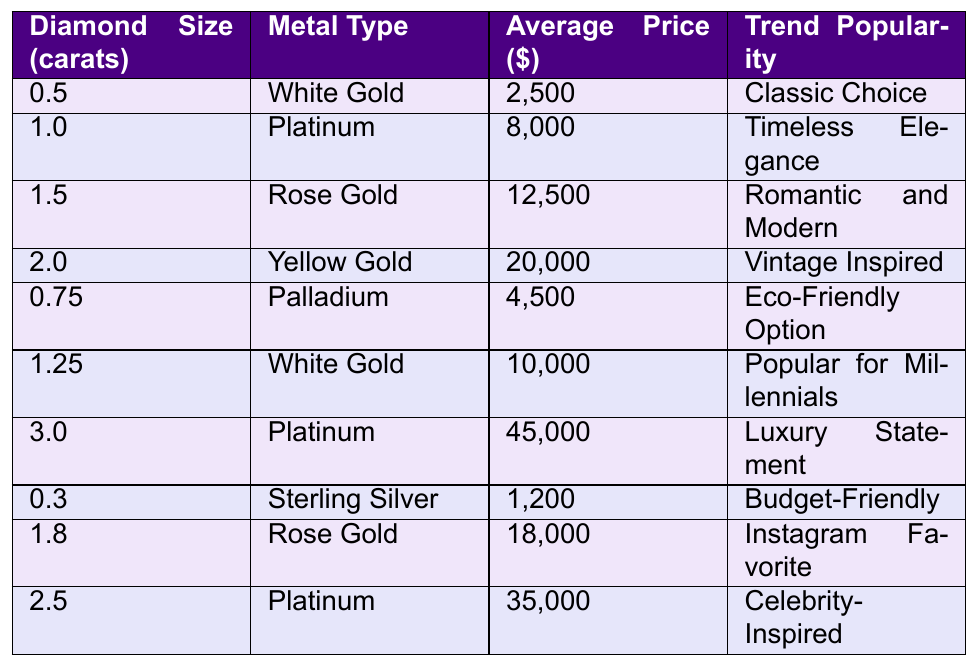What is the average price of a 1.0 carat diamond in Platinum? The table states that the average price for a 1.0 carat diamond in Platinum is $8,000.
Answer: $8,000 Which metal type is associated with the highest average price? According to the table, Platinum has the highest average price of $45,000 for a 3.0 carat diamond.
Answer: Platinum True or False: A 0.3 carat diamond in Sterling Silver costs more than a 1.25 carat diamond in White Gold. The average price of a 0.3 carat diamond in Sterling Silver is $1,200, while the 1.25 carat diamond in White Gold is $10,000. Since $1,200 is less than $10,000, the statement is False.
Answer: False What is the total average price of all diamond sizes in Platinum? The total average prices for diamonds in Platinum are $8,000 (1.0 carat), $45,000 (3.0 carat), and $35,000 (2.5 carat). When summed, the total is $8,000 + $45,000 + $35,000 = $88,000.
Answer: $88,000 What is the trend popularity for diamonds in Rose Gold? The table lists two diamond sizes in Rose Gold: the 1.5 carat diamond is labeled as "Romantic and Modern," and the 1.8 carat diamond is noted as "Instagram Favorite."
Answer: Romantic and Modern; Instagram Favorite Which diamond size has the lowest average price and what is it? Looking at the table, the lowest average price is $1,200 for a 0.3 carat diamond in Sterling Silver.
Answer: $1,200 What is the average cost of a diamond larger than 2.0 carats? The table includes diamonds larger than 2.0 carats: the 2.5 carat diamond ($35,000) and the 3.0 carat diamond ($45,000). Adding these gives $35,000 + $45,000 = $80,000. Dividing by the count of 2 yields an average of $80,000 / 2 = $40,000.
Answer: $40,000 Which trend is popular among millennials? The table indicates that a 1.25 carat ring in White Gold is marked as "Popular for Millennials."
Answer: Popular for Millennials How many metal types are listed for diamonds over 1.0 carat? The table lists five metal types for diamonds over 1.0 carat: Platinum (1.0, 2.5, and 3.0 carats), Rose Gold (1.5 and 1.8 carats), and Yellow Gold (2.0 carats). This makes a total of 3 different metal types.
Answer: 3 What is the average price for all diamond sizes in White Gold? The table shows two entries for White Gold: $2,500 (for 0.5 carats) and $10,000 (for 1.25 carats). Their total is $2,500 + $10,000 = $12,500. The average would be $12,500 / 2 = $6,250.
Answer: $6,250 